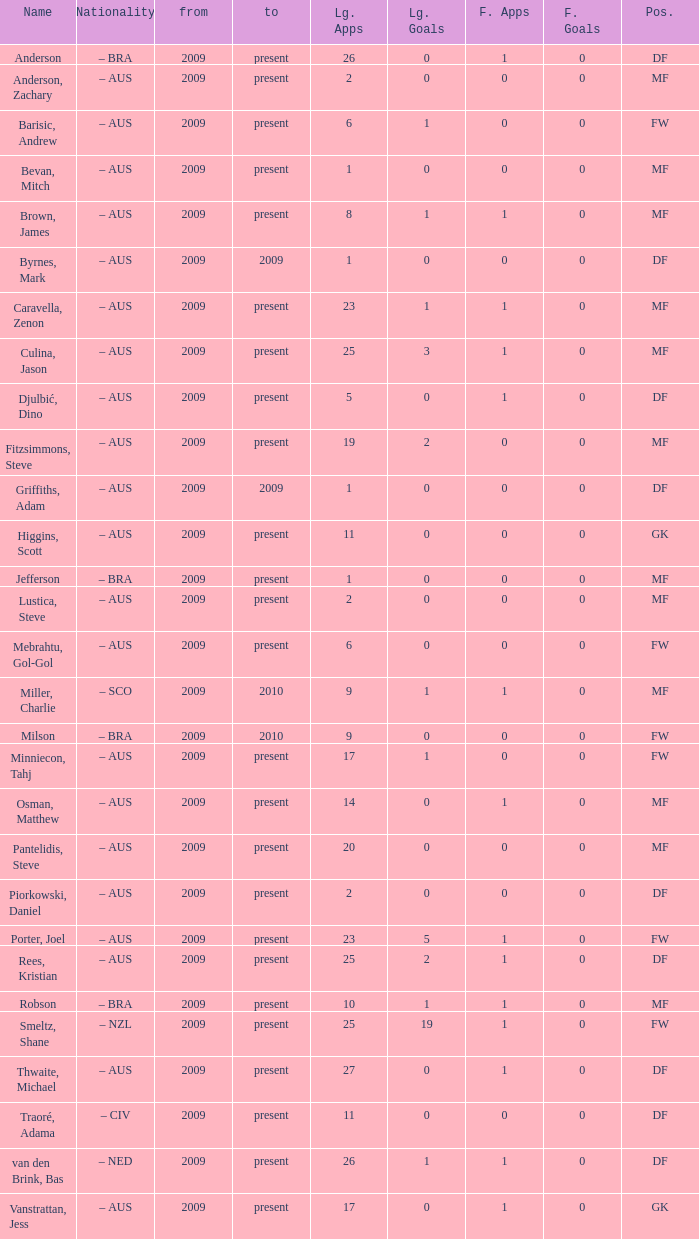Name the position for van den brink, bas DF. 